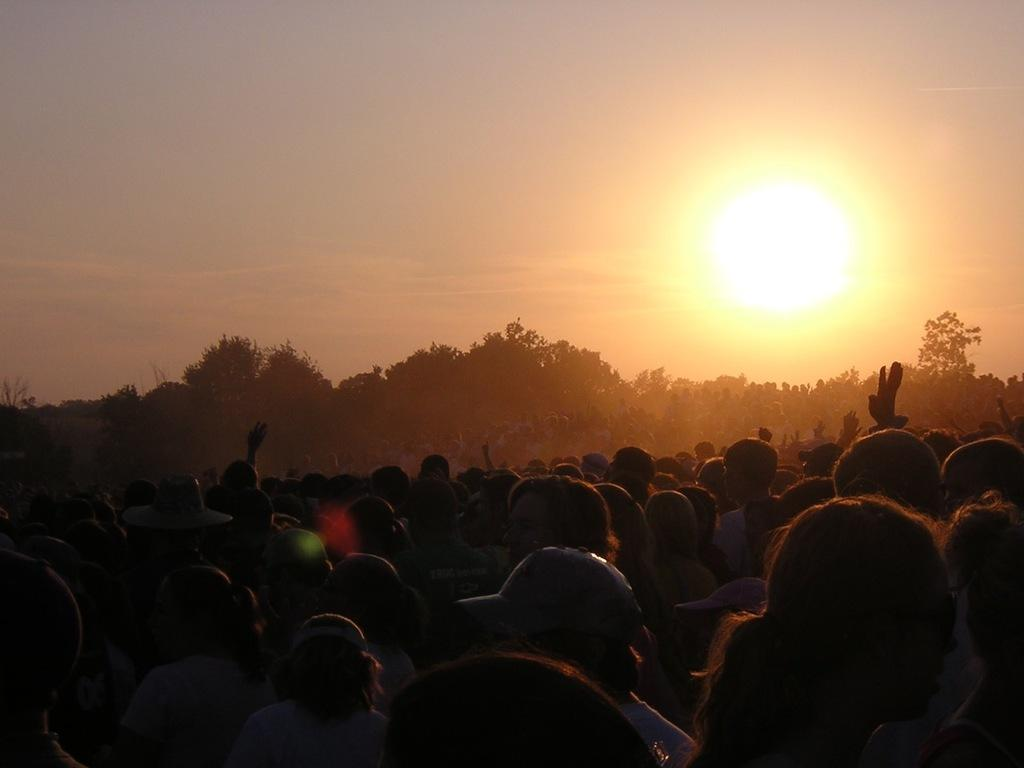Who or what is present in the image? There are people in the image. What can be seen in the background of the image? There are trees in the background of the image. What is visible in the sky in the image? The sun is visible in the sky in the image. What type of stone is being used as a club by the people in the image? There is no stone or club present in the image; it only features people and trees in the background. 